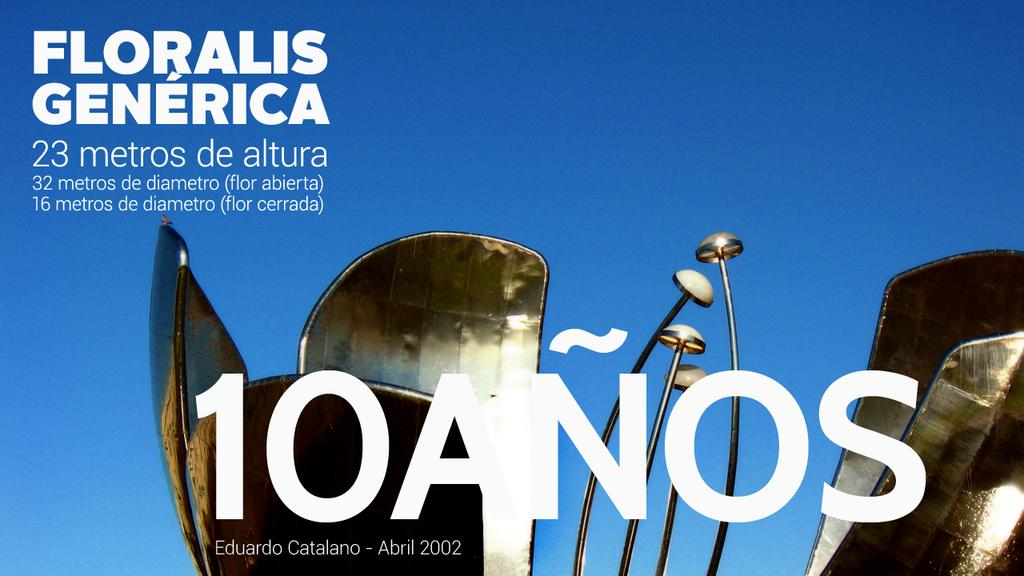<image>
Write a terse but informative summary of the picture. An ad celebrating 10 Anos features a bright blue sky and features the words "Floralis Generica." 